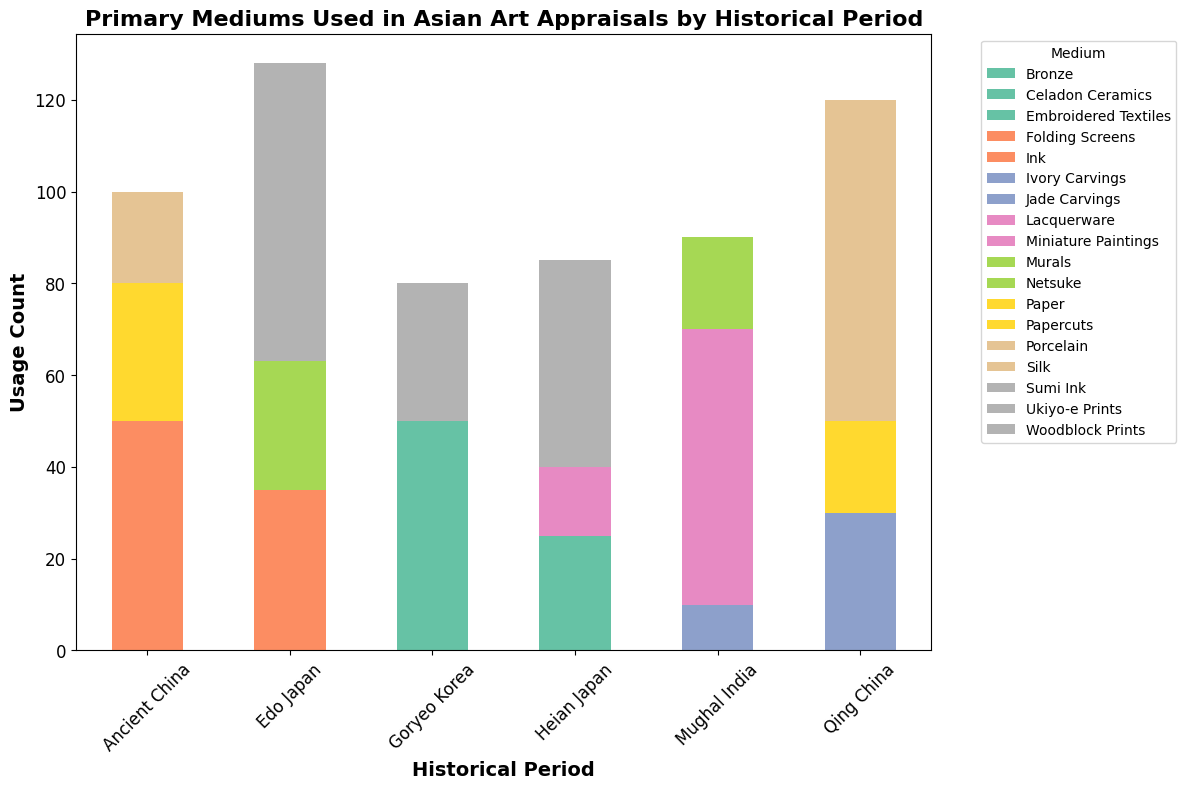Which medium was used the most in Ancient China? By examining the bars corresponding to Ancient China, the tallest bar represents the most used medium. Ink has the highest count.
Answer: Ink Between Heian Japan and Edo Japan, which period used more Sumi Ink and Ukiyo-e Prints combined? Compare the sum of Sumi Ink in Heian Japan and Ukiyo-e Prints in Edo Japan. Heian Japan has 45 Sumi Ink, and Edo Japan has 65 Ukiyo-e Prints. 65 (Edo Japan) is greater than 45 (Heian Japan).
Answer: Edo Japan What is the least used medium in Goryeo Korea? Look at the bars for Goryeo Korea and identify the shortest one. Bronze has the shortest bar.
Answer: Bronze How much more Porcelain was used in Qing China compared to Jade Carvings? Subtract the usage count of Jade Carvings from Porcelain in Qing China. Porcelain is 70 and Jade Carvings are 30, therefore, 70 - 30 = 40.
Answer: 40 Which period has the highest usage count for a single medium overall? Identify the highest single bar across all periods. Porcelain in Qing China has the highest count at 70.
Answer: Qing China What is the combined usage count of Murals and Ivory Carvings in Mughal India? Add the usage counts of Murals and Ivory Carvings in Mughal India. Murals are 20 and Ivory Carvings are 10, so 20 + 10 = 30.
Answer: 30 Among the mediums used in Edo Japan, which one has the lowest count? Identify the shortest bar among the mediums used in Edo Japan. Netsuke has the lowest count.
Answer: Netsuke How does the usage of Celadon Ceramics in Goryeo Korea compare to the usage of Porcelain in Qing China? Compare the heights of the bars for Celadon Ceramics and Porcelain. Porcelain in Qing China (70) is taller than Celadon Ceramics in Goryeo Korea (40).
Answer: Less What's the total usage count for all mediums in Ancient China? Sum the usage counts for all mediums in Ancient China. Ink 50 + Paper 30 + Silk 20 = 100.
Answer: 100 